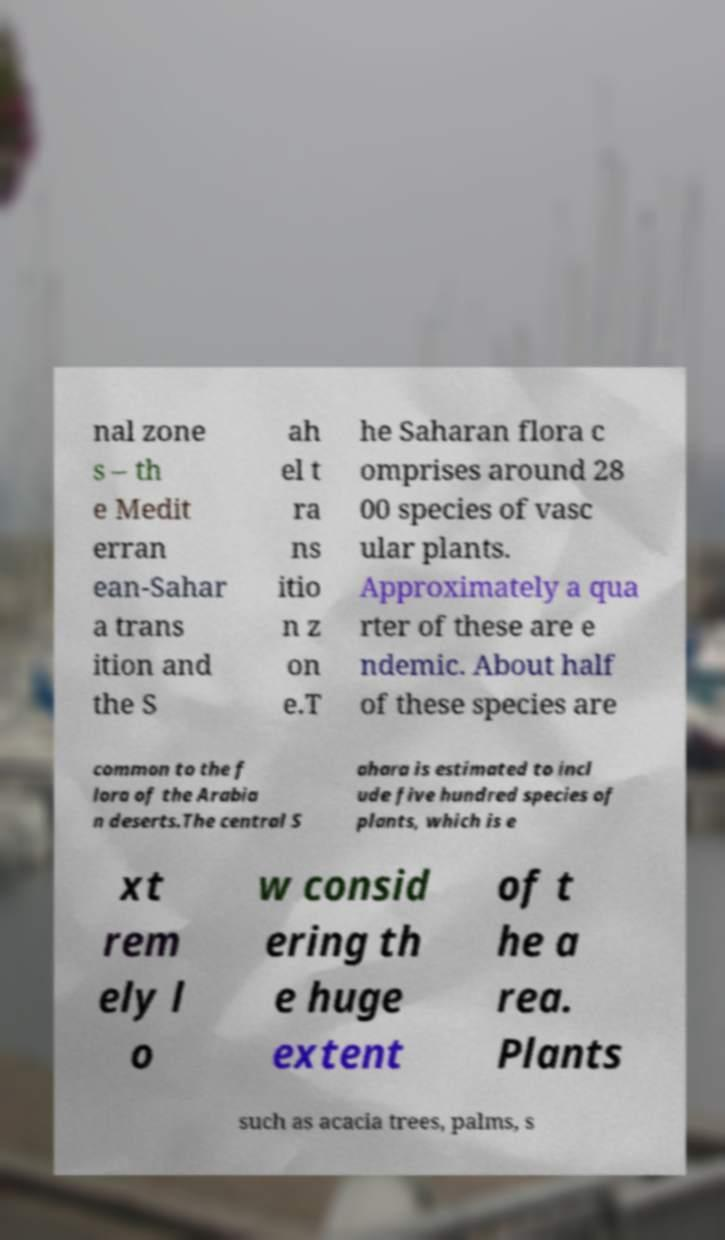Can you accurately transcribe the text from the provided image for me? nal zone s – th e Medit erran ean-Sahar a trans ition and the S ah el t ra ns itio n z on e.T he Saharan flora c omprises around 28 00 species of vasc ular plants. Approximately a qua rter of these are e ndemic. About half of these species are common to the f lora of the Arabia n deserts.The central S ahara is estimated to incl ude five hundred species of plants, which is e xt rem ely l o w consid ering th e huge extent of t he a rea. Plants such as acacia trees, palms, s 